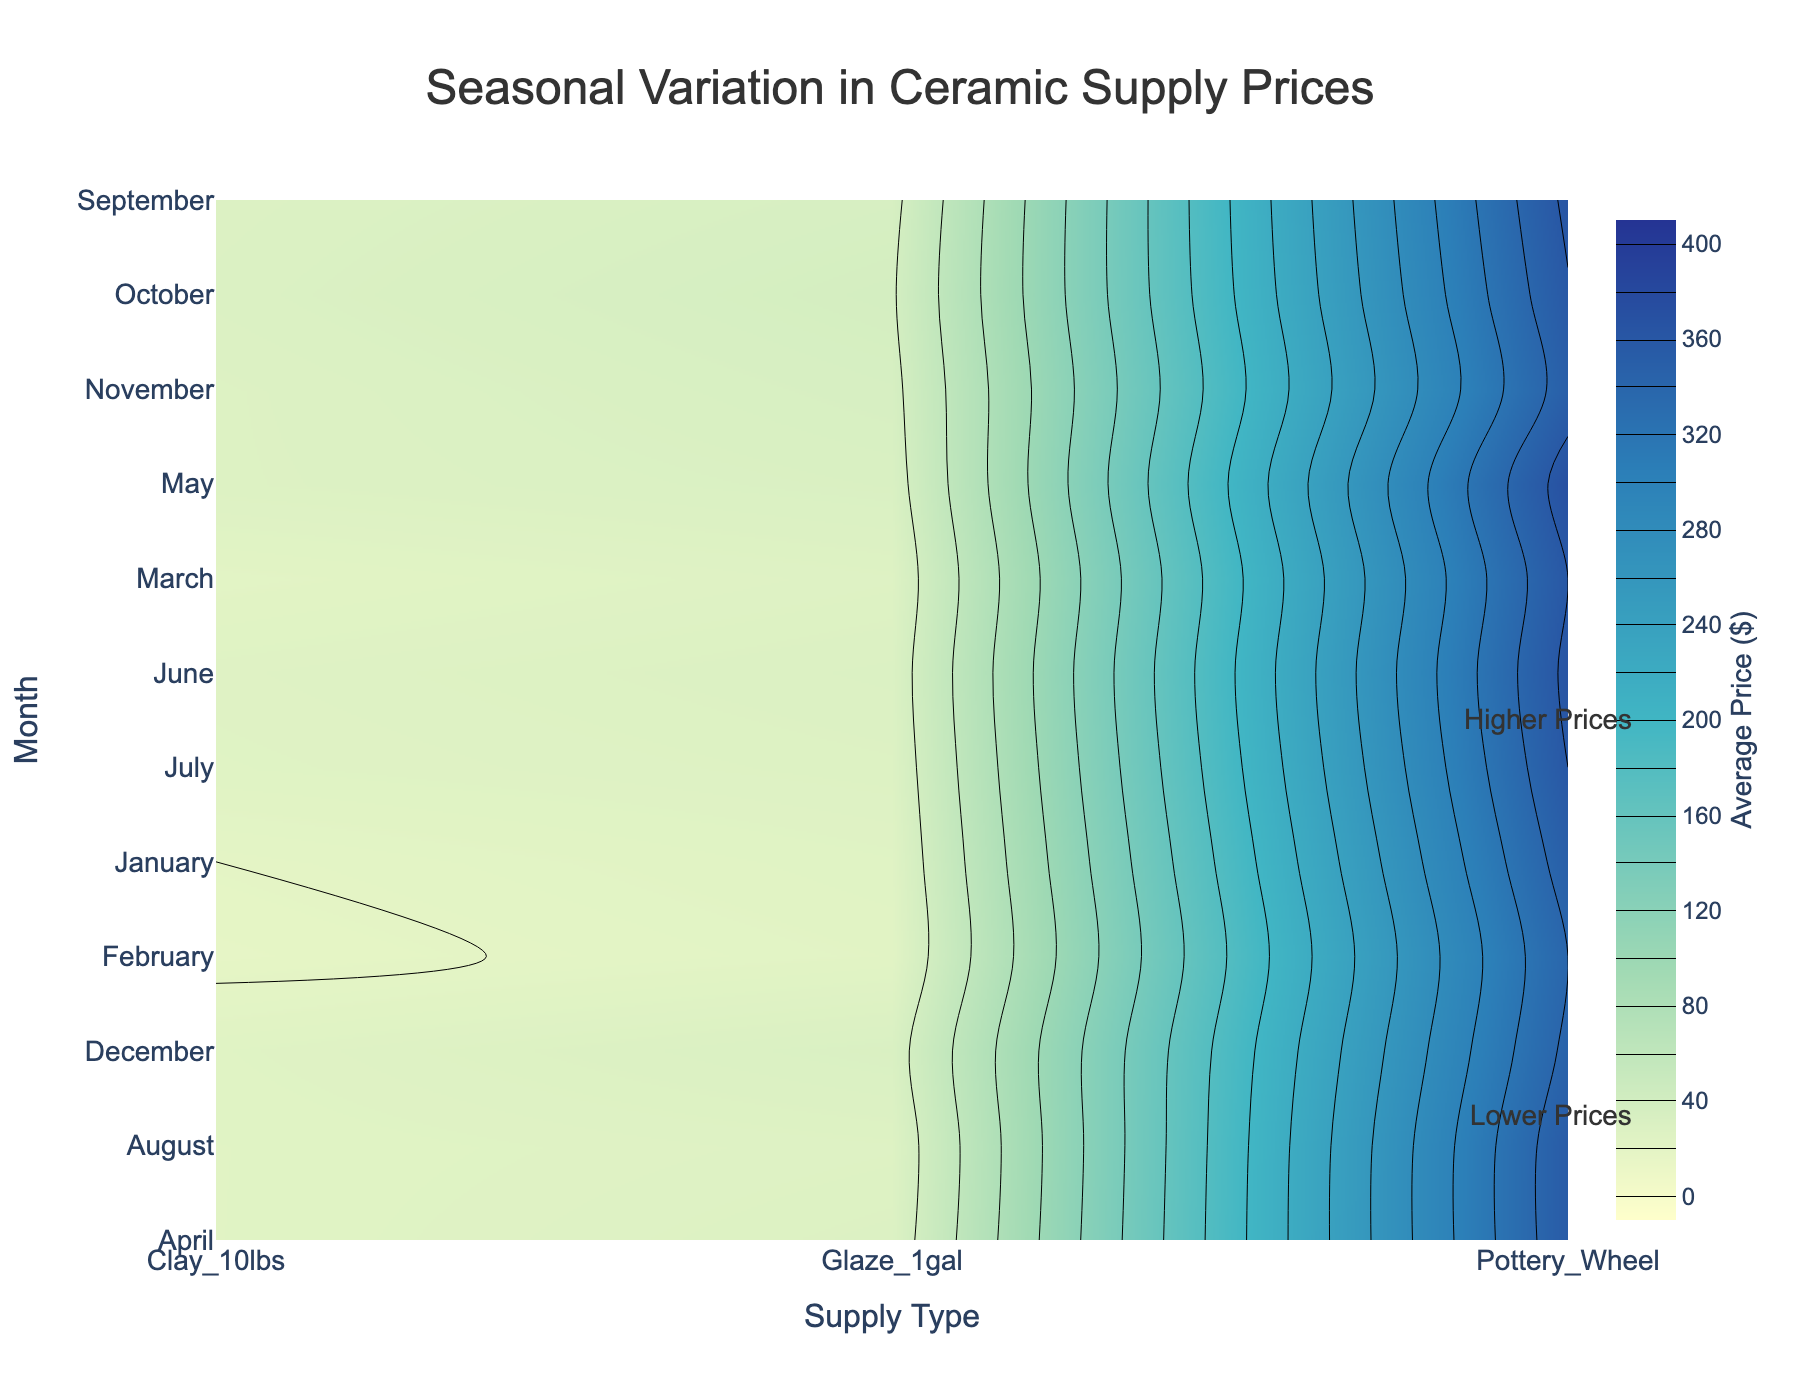What's the title of the figure? The title is usually prominently displayed at the top of the figure. For this plot, it is shown as "Seasonal Variation in Ceramic Supply Prices".
Answer: Seasonal Variation in Ceramic Supply Prices What are the y-axis labels indicating? The y-axis labels represent the months, shown in sequence from January to December to indicate the time of the year.
Answer: Months How does the price of Clay_10lbs change from January to October? By observing the contour lines and color gradients for Clay_10lbs, the price increases from $20 in January to $30 in October, following a somewhat gradual increase.
Answer: Increases from $20 to $30 During which month is the price of Glaze_1gal highest, and what is the price? The highest price can be found by observing the contour lines and colors. The price of Glaze_1gal peaks in October at $38.
Answer: October, $38 Compare the availability of Clay_10lbs in July and May. By visually comparing the contours in the figure, May shows a higher availability for Clay_10lbs than July.
Answer: Higher in May What's the average price difference of Pottery Wheel between March and November? The price of the Pottery Wheel in March is $360, and in November it is $350. The difference is calculated as $360 - $350 = $10.
Answer: $10 What color on the contour plot represents the highest prices? According to the colorscale provided, the highest prices are represented in the darkest color, which is a deep blue.
Answer: Deep blue Which month shows the lowest price for Clay_10lbs, and what is that price? The lowest price is identified by the lightest color in the contour plot. January shows the lowest price for Clay_10lbs at $20.
Answer: January, $20 By how much does the price of Glaze_1gal increase from February to September? From the contour plot, the price of Glaze_1gal in February is $23, and in September it is $35. The price increase is calculated as $35 - $23 = $12.
Answer: $12 Which supply has the least price variation over the months? Comparing the contour changes across months for each supply type, the Pottery Wheel shows the least variation in price, remaining relatively stable around $350 - $370.
Answer: Pottery Wheel 